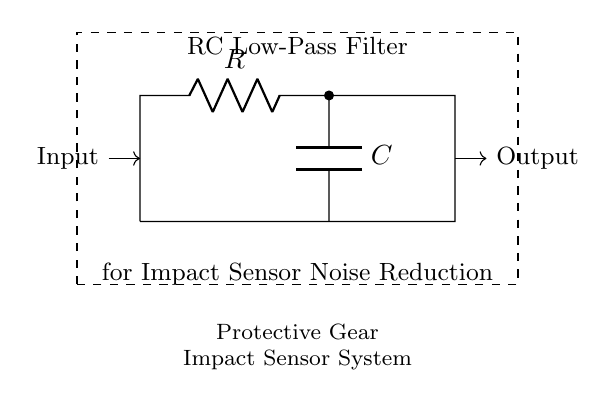What components are present in the circuit? The circuit includes a resistor and a capacitor, which are the primary components in an RC low-pass filter. This is identifiable as the circuit diagram explicitly labels these components as R and C.
Answer: Resistor and Capacitor What is the function of the capacitor in this RC circuit? The capacitor in this circuit serves to filter out high-frequency noise, allowing only low-frequency signals to pass through. This is specific for noise reduction in the context of impact sensors.
Answer: Noise reduction What does the input represent in the circuit? The input represents the signal from the impact sensor, which could contain high-frequency noise. It's where the initial signal, which needs to be filtered, enters the RC circuit.
Answer: Signal from impact sensor What type of filter is represented in this circuit? This circuit represents a low-pass filter, which allows low-frequency signals to pass while attenuating higher frequencies. Given its design with a resistor and capacitor, it follows the characteristics of an RC low-pass filter.
Answer: Low-pass filter What is the overall purpose of this RC low-pass filter? The overall purpose is to reduce noise in the impact sensor system used in protective gear. In sporting contexts, reducing noise helps to prevent false readings and ensure accurate sensor performance.
Answer: Noise reduction in protective gear What happens to high-frequency noise signals in this circuit? High-frequency noise signals are attenuated or reduced in amplitude as they pass through the filter. The combination of the resistor and capacitor creates a circuit that prevents high frequencies from reaching the output.
Answer: Attenuated At what point is the output taken in this circuit? The output is taken from the junction between the capacitor and ground in this circuit, which allows the filtered signal to exit the system after passing through the capacitor.
Answer: From the capacitor 